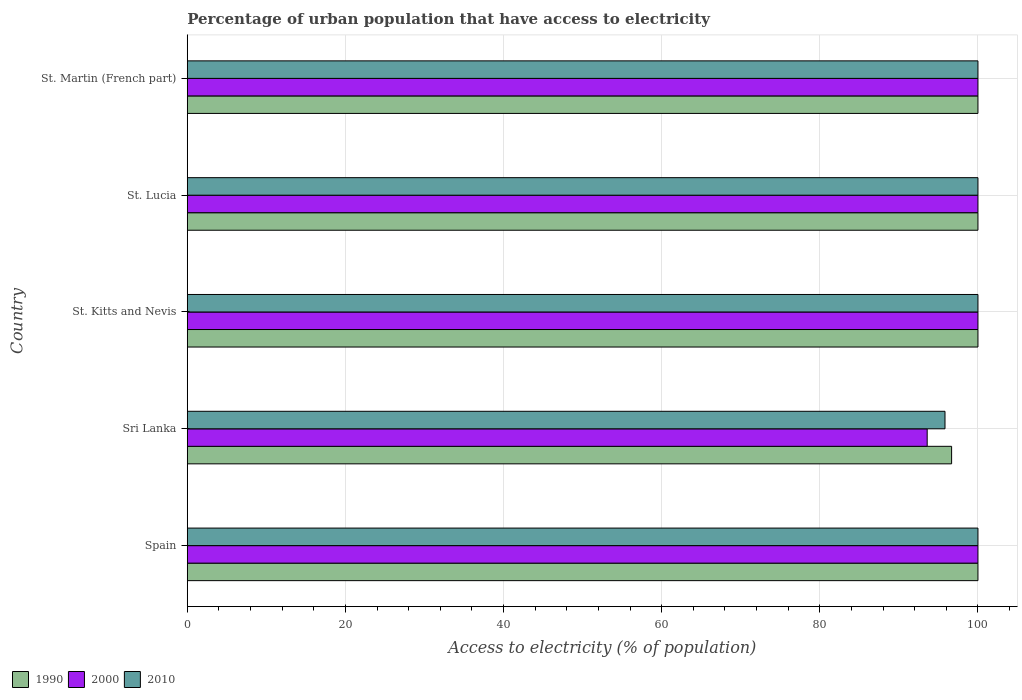How many different coloured bars are there?
Give a very brief answer. 3. How many groups of bars are there?
Give a very brief answer. 5. Are the number of bars per tick equal to the number of legend labels?
Your answer should be very brief. Yes. Are the number of bars on each tick of the Y-axis equal?
Offer a terse response. Yes. What is the label of the 4th group of bars from the top?
Give a very brief answer. Sri Lanka. What is the percentage of urban population that have access to electricity in 2000 in St. Kitts and Nevis?
Give a very brief answer. 100. Across all countries, what is the minimum percentage of urban population that have access to electricity in 1990?
Offer a very short reply. 96.67. In which country was the percentage of urban population that have access to electricity in 2010 minimum?
Provide a succinct answer. Sri Lanka. What is the total percentage of urban population that have access to electricity in 2010 in the graph?
Make the answer very short. 495.83. What is the difference between the percentage of urban population that have access to electricity in 2010 in Sri Lanka and the percentage of urban population that have access to electricity in 1990 in Spain?
Give a very brief answer. -4.17. What is the average percentage of urban population that have access to electricity in 1990 per country?
Your answer should be compact. 99.33. What is the difference between the percentage of urban population that have access to electricity in 1990 and percentage of urban population that have access to electricity in 2010 in St. Kitts and Nevis?
Keep it short and to the point. 0. In how many countries, is the percentage of urban population that have access to electricity in 2010 greater than 80 %?
Make the answer very short. 5. What is the ratio of the percentage of urban population that have access to electricity in 2000 in Sri Lanka to that in St. Martin (French part)?
Your answer should be compact. 0.94. Is the difference between the percentage of urban population that have access to electricity in 1990 in Spain and St. Lucia greater than the difference between the percentage of urban population that have access to electricity in 2010 in Spain and St. Lucia?
Provide a succinct answer. No. What is the difference between the highest and the second highest percentage of urban population that have access to electricity in 1990?
Make the answer very short. 0. What is the difference between the highest and the lowest percentage of urban population that have access to electricity in 1990?
Your answer should be compact. 3.33. Is it the case that in every country, the sum of the percentage of urban population that have access to electricity in 1990 and percentage of urban population that have access to electricity in 2010 is greater than the percentage of urban population that have access to electricity in 2000?
Make the answer very short. Yes. How many countries are there in the graph?
Provide a succinct answer. 5. Where does the legend appear in the graph?
Provide a short and direct response. Bottom left. How many legend labels are there?
Keep it short and to the point. 3. What is the title of the graph?
Provide a succinct answer. Percentage of urban population that have access to electricity. Does "2011" appear as one of the legend labels in the graph?
Keep it short and to the point. No. What is the label or title of the X-axis?
Provide a succinct answer. Access to electricity (% of population). What is the label or title of the Y-axis?
Your answer should be compact. Country. What is the Access to electricity (% of population) of 2000 in Spain?
Your response must be concise. 100. What is the Access to electricity (% of population) of 1990 in Sri Lanka?
Offer a very short reply. 96.67. What is the Access to electricity (% of population) of 2000 in Sri Lanka?
Offer a terse response. 93.58. What is the Access to electricity (% of population) of 2010 in Sri Lanka?
Provide a succinct answer. 95.83. What is the Access to electricity (% of population) in 2000 in St. Lucia?
Your answer should be very brief. 100. What is the Access to electricity (% of population) of 2010 in St. Martin (French part)?
Give a very brief answer. 100. Across all countries, what is the maximum Access to electricity (% of population) of 2010?
Keep it short and to the point. 100. Across all countries, what is the minimum Access to electricity (% of population) of 1990?
Your response must be concise. 96.67. Across all countries, what is the minimum Access to electricity (% of population) in 2000?
Provide a succinct answer. 93.58. Across all countries, what is the minimum Access to electricity (% of population) of 2010?
Your answer should be compact. 95.83. What is the total Access to electricity (% of population) in 1990 in the graph?
Provide a short and direct response. 496.67. What is the total Access to electricity (% of population) in 2000 in the graph?
Your answer should be compact. 493.58. What is the total Access to electricity (% of population) in 2010 in the graph?
Make the answer very short. 495.83. What is the difference between the Access to electricity (% of population) in 1990 in Spain and that in Sri Lanka?
Make the answer very short. 3.33. What is the difference between the Access to electricity (% of population) in 2000 in Spain and that in Sri Lanka?
Your answer should be compact. 6.42. What is the difference between the Access to electricity (% of population) in 2010 in Spain and that in Sri Lanka?
Offer a terse response. 4.17. What is the difference between the Access to electricity (% of population) in 2010 in Spain and that in St. Kitts and Nevis?
Provide a short and direct response. 0. What is the difference between the Access to electricity (% of population) of 2010 in Spain and that in St. Lucia?
Provide a short and direct response. 0. What is the difference between the Access to electricity (% of population) of 1990 in Spain and that in St. Martin (French part)?
Ensure brevity in your answer.  0. What is the difference between the Access to electricity (% of population) in 2010 in Spain and that in St. Martin (French part)?
Your response must be concise. 0. What is the difference between the Access to electricity (% of population) of 1990 in Sri Lanka and that in St. Kitts and Nevis?
Provide a short and direct response. -3.33. What is the difference between the Access to electricity (% of population) in 2000 in Sri Lanka and that in St. Kitts and Nevis?
Provide a succinct answer. -6.42. What is the difference between the Access to electricity (% of population) in 2010 in Sri Lanka and that in St. Kitts and Nevis?
Offer a terse response. -4.17. What is the difference between the Access to electricity (% of population) of 1990 in Sri Lanka and that in St. Lucia?
Keep it short and to the point. -3.33. What is the difference between the Access to electricity (% of population) in 2000 in Sri Lanka and that in St. Lucia?
Offer a terse response. -6.42. What is the difference between the Access to electricity (% of population) of 2010 in Sri Lanka and that in St. Lucia?
Keep it short and to the point. -4.17. What is the difference between the Access to electricity (% of population) in 1990 in Sri Lanka and that in St. Martin (French part)?
Provide a short and direct response. -3.33. What is the difference between the Access to electricity (% of population) in 2000 in Sri Lanka and that in St. Martin (French part)?
Make the answer very short. -6.42. What is the difference between the Access to electricity (% of population) of 2010 in Sri Lanka and that in St. Martin (French part)?
Your response must be concise. -4.17. What is the difference between the Access to electricity (% of population) in 1990 in St. Kitts and Nevis and that in St. Lucia?
Give a very brief answer. 0. What is the difference between the Access to electricity (% of population) in 2000 in St. Kitts and Nevis and that in St. Lucia?
Provide a short and direct response. 0. What is the difference between the Access to electricity (% of population) of 2010 in St. Kitts and Nevis and that in St. Lucia?
Provide a short and direct response. 0. What is the difference between the Access to electricity (% of population) of 2000 in St. Kitts and Nevis and that in St. Martin (French part)?
Offer a very short reply. 0. What is the difference between the Access to electricity (% of population) in 2010 in St. Kitts and Nevis and that in St. Martin (French part)?
Make the answer very short. 0. What is the difference between the Access to electricity (% of population) in 2010 in St. Lucia and that in St. Martin (French part)?
Your answer should be very brief. 0. What is the difference between the Access to electricity (% of population) of 1990 in Spain and the Access to electricity (% of population) of 2000 in Sri Lanka?
Your response must be concise. 6.42. What is the difference between the Access to electricity (% of population) of 1990 in Spain and the Access to electricity (% of population) of 2010 in Sri Lanka?
Your answer should be compact. 4.17. What is the difference between the Access to electricity (% of population) in 2000 in Spain and the Access to electricity (% of population) in 2010 in Sri Lanka?
Offer a terse response. 4.17. What is the difference between the Access to electricity (% of population) in 1990 in Spain and the Access to electricity (% of population) in 2000 in St. Kitts and Nevis?
Offer a terse response. 0. What is the difference between the Access to electricity (% of population) of 1990 in Spain and the Access to electricity (% of population) of 2000 in St. Lucia?
Provide a short and direct response. 0. What is the difference between the Access to electricity (% of population) of 2000 in Spain and the Access to electricity (% of population) of 2010 in St. Lucia?
Offer a terse response. 0. What is the difference between the Access to electricity (% of population) in 1990 in Spain and the Access to electricity (% of population) in 2000 in St. Martin (French part)?
Provide a succinct answer. 0. What is the difference between the Access to electricity (% of population) in 1990 in Spain and the Access to electricity (% of population) in 2010 in St. Martin (French part)?
Offer a very short reply. 0. What is the difference between the Access to electricity (% of population) of 1990 in Sri Lanka and the Access to electricity (% of population) of 2000 in St. Kitts and Nevis?
Offer a very short reply. -3.33. What is the difference between the Access to electricity (% of population) of 1990 in Sri Lanka and the Access to electricity (% of population) of 2010 in St. Kitts and Nevis?
Provide a short and direct response. -3.33. What is the difference between the Access to electricity (% of population) of 2000 in Sri Lanka and the Access to electricity (% of population) of 2010 in St. Kitts and Nevis?
Keep it short and to the point. -6.42. What is the difference between the Access to electricity (% of population) in 1990 in Sri Lanka and the Access to electricity (% of population) in 2000 in St. Lucia?
Offer a terse response. -3.33. What is the difference between the Access to electricity (% of population) in 1990 in Sri Lanka and the Access to electricity (% of population) in 2010 in St. Lucia?
Give a very brief answer. -3.33. What is the difference between the Access to electricity (% of population) of 2000 in Sri Lanka and the Access to electricity (% of population) of 2010 in St. Lucia?
Give a very brief answer. -6.42. What is the difference between the Access to electricity (% of population) in 1990 in Sri Lanka and the Access to electricity (% of population) in 2000 in St. Martin (French part)?
Offer a very short reply. -3.33. What is the difference between the Access to electricity (% of population) of 1990 in Sri Lanka and the Access to electricity (% of population) of 2010 in St. Martin (French part)?
Give a very brief answer. -3.33. What is the difference between the Access to electricity (% of population) in 2000 in Sri Lanka and the Access to electricity (% of population) in 2010 in St. Martin (French part)?
Make the answer very short. -6.42. What is the difference between the Access to electricity (% of population) of 1990 in St. Kitts and Nevis and the Access to electricity (% of population) of 2010 in St. Lucia?
Give a very brief answer. 0. What is the difference between the Access to electricity (% of population) in 1990 in St. Kitts and Nevis and the Access to electricity (% of population) in 2000 in St. Martin (French part)?
Your response must be concise. 0. What is the difference between the Access to electricity (% of population) in 1990 in St. Kitts and Nevis and the Access to electricity (% of population) in 2010 in St. Martin (French part)?
Ensure brevity in your answer.  0. What is the difference between the Access to electricity (% of population) of 2000 in St. Kitts and Nevis and the Access to electricity (% of population) of 2010 in St. Martin (French part)?
Offer a terse response. 0. What is the difference between the Access to electricity (% of population) in 1990 in St. Lucia and the Access to electricity (% of population) in 2000 in St. Martin (French part)?
Make the answer very short. 0. What is the average Access to electricity (% of population) of 1990 per country?
Offer a terse response. 99.33. What is the average Access to electricity (% of population) in 2000 per country?
Offer a terse response. 98.72. What is the average Access to electricity (% of population) of 2010 per country?
Keep it short and to the point. 99.17. What is the difference between the Access to electricity (% of population) in 1990 and Access to electricity (% of population) in 2000 in Sri Lanka?
Give a very brief answer. 3.09. What is the difference between the Access to electricity (% of population) of 1990 and Access to electricity (% of population) of 2010 in Sri Lanka?
Your answer should be very brief. 0.84. What is the difference between the Access to electricity (% of population) in 2000 and Access to electricity (% of population) in 2010 in Sri Lanka?
Offer a terse response. -2.25. What is the difference between the Access to electricity (% of population) of 1990 and Access to electricity (% of population) of 2000 in St. Kitts and Nevis?
Offer a very short reply. 0. What is the difference between the Access to electricity (% of population) of 2000 and Access to electricity (% of population) of 2010 in St. Kitts and Nevis?
Provide a succinct answer. 0. What is the difference between the Access to electricity (% of population) in 1990 and Access to electricity (% of population) in 2010 in St. Lucia?
Provide a short and direct response. 0. What is the difference between the Access to electricity (% of population) of 2000 and Access to electricity (% of population) of 2010 in St. Lucia?
Provide a short and direct response. 0. What is the difference between the Access to electricity (% of population) in 1990 and Access to electricity (% of population) in 2000 in St. Martin (French part)?
Offer a very short reply. 0. What is the difference between the Access to electricity (% of population) in 1990 and Access to electricity (% of population) in 2010 in St. Martin (French part)?
Provide a short and direct response. 0. What is the ratio of the Access to electricity (% of population) in 1990 in Spain to that in Sri Lanka?
Make the answer very short. 1.03. What is the ratio of the Access to electricity (% of population) of 2000 in Spain to that in Sri Lanka?
Your response must be concise. 1.07. What is the ratio of the Access to electricity (% of population) in 2010 in Spain to that in Sri Lanka?
Your answer should be compact. 1.04. What is the ratio of the Access to electricity (% of population) in 1990 in Spain to that in St. Martin (French part)?
Offer a terse response. 1. What is the ratio of the Access to electricity (% of population) of 2000 in Spain to that in St. Martin (French part)?
Ensure brevity in your answer.  1. What is the ratio of the Access to electricity (% of population) of 1990 in Sri Lanka to that in St. Kitts and Nevis?
Offer a terse response. 0.97. What is the ratio of the Access to electricity (% of population) in 2000 in Sri Lanka to that in St. Kitts and Nevis?
Ensure brevity in your answer.  0.94. What is the ratio of the Access to electricity (% of population) of 1990 in Sri Lanka to that in St. Lucia?
Keep it short and to the point. 0.97. What is the ratio of the Access to electricity (% of population) in 2000 in Sri Lanka to that in St. Lucia?
Your answer should be very brief. 0.94. What is the ratio of the Access to electricity (% of population) of 2010 in Sri Lanka to that in St. Lucia?
Offer a terse response. 0.96. What is the ratio of the Access to electricity (% of population) in 1990 in Sri Lanka to that in St. Martin (French part)?
Your response must be concise. 0.97. What is the ratio of the Access to electricity (% of population) in 2000 in Sri Lanka to that in St. Martin (French part)?
Keep it short and to the point. 0.94. What is the ratio of the Access to electricity (% of population) of 1990 in St. Kitts and Nevis to that in St. Lucia?
Give a very brief answer. 1. What is the ratio of the Access to electricity (% of population) in 2010 in St. Kitts and Nevis to that in St. Lucia?
Offer a very short reply. 1. What is the ratio of the Access to electricity (% of population) of 2010 in St. Kitts and Nevis to that in St. Martin (French part)?
Provide a succinct answer. 1. What is the ratio of the Access to electricity (% of population) of 1990 in St. Lucia to that in St. Martin (French part)?
Give a very brief answer. 1. What is the ratio of the Access to electricity (% of population) of 2000 in St. Lucia to that in St. Martin (French part)?
Offer a terse response. 1. What is the difference between the highest and the second highest Access to electricity (% of population) in 1990?
Provide a succinct answer. 0. What is the difference between the highest and the lowest Access to electricity (% of population) in 1990?
Provide a succinct answer. 3.33. What is the difference between the highest and the lowest Access to electricity (% of population) of 2000?
Give a very brief answer. 6.42. What is the difference between the highest and the lowest Access to electricity (% of population) of 2010?
Ensure brevity in your answer.  4.17. 